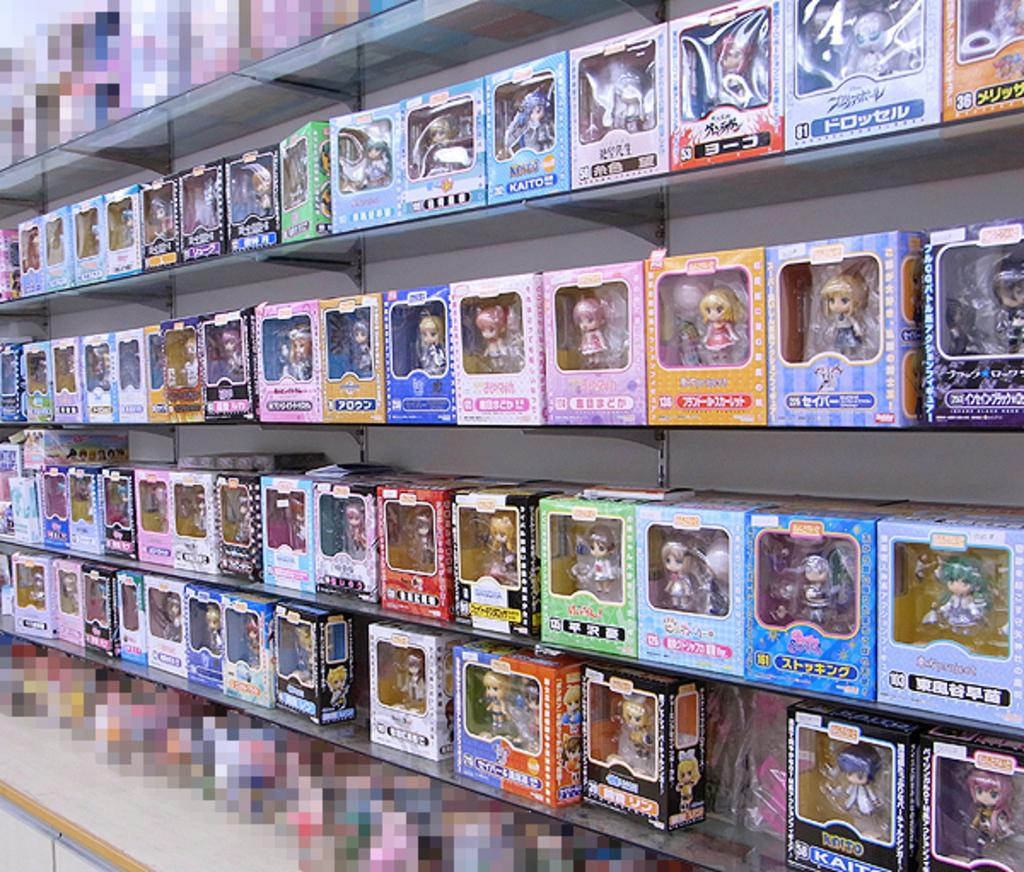<image>
Relay a brief, clear account of the picture shown. Toys on a shelf with different numbers like 81 